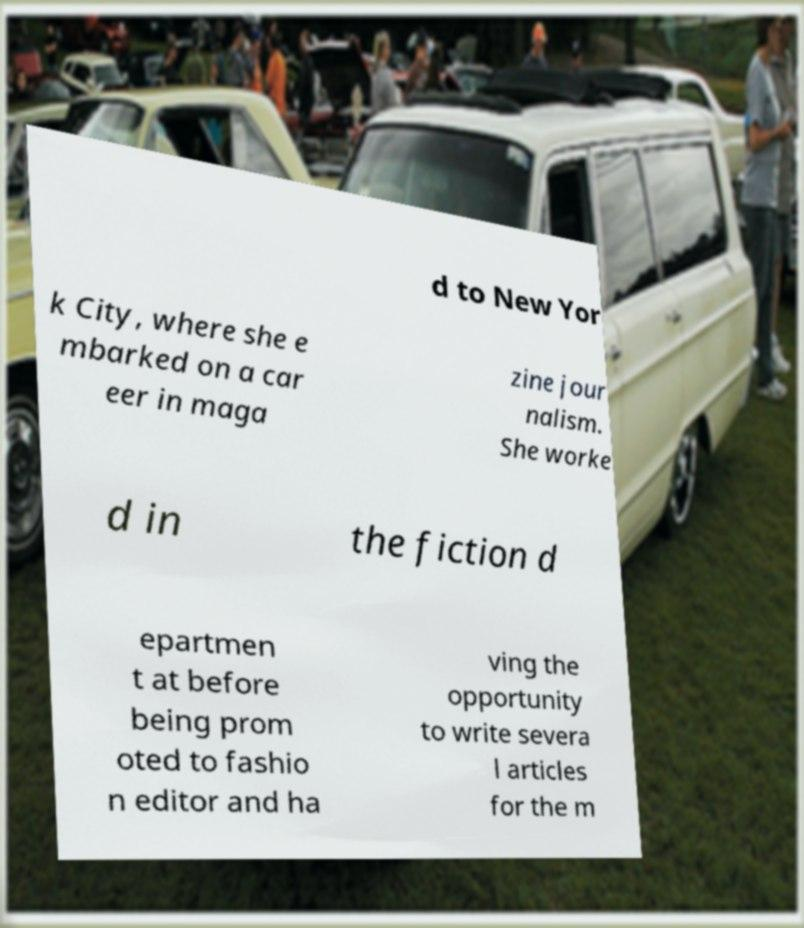Please read and relay the text visible in this image. What does it say? d to New Yor k City, where she e mbarked on a car eer in maga zine jour nalism. She worke d in the fiction d epartmen t at before being prom oted to fashio n editor and ha ving the opportunity to write severa l articles for the m 